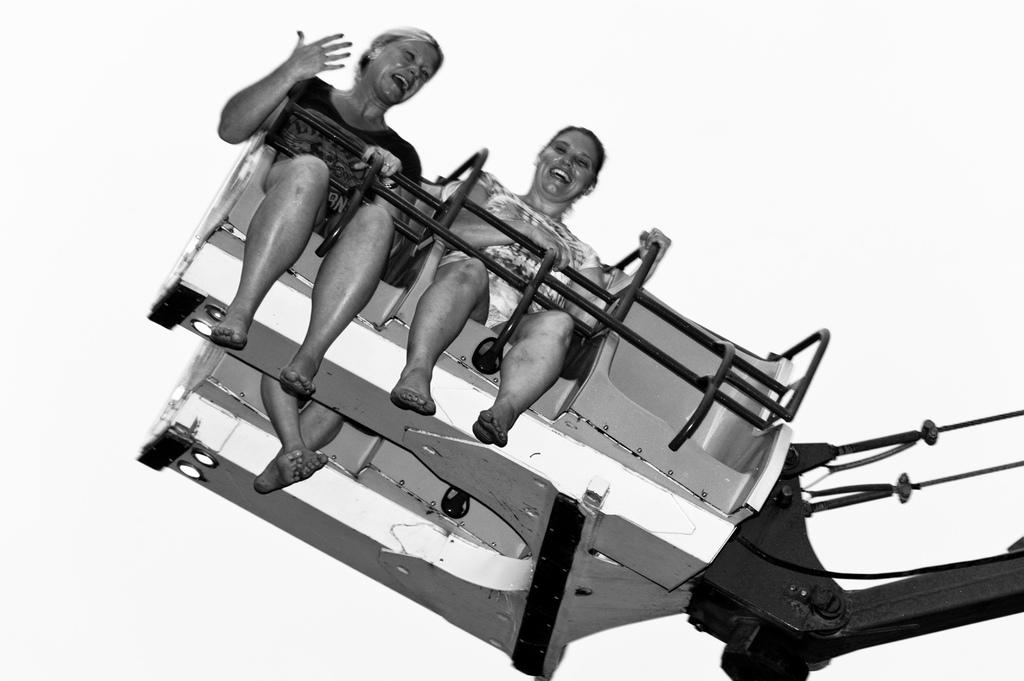What is the color scheme of the image? The image is black and white. Who or what is the main subject of the image? There are women in the center of the image. What are the women doing in the image? The women are on a ride. What can be seen in the background of the image? There is a sky visible in the background of the image. How many stems are visible in the image? There are no stems present in the image. What type of cub can be seen playing with the women on the ride? There is no cub present in the image; it features only women on a ride. 